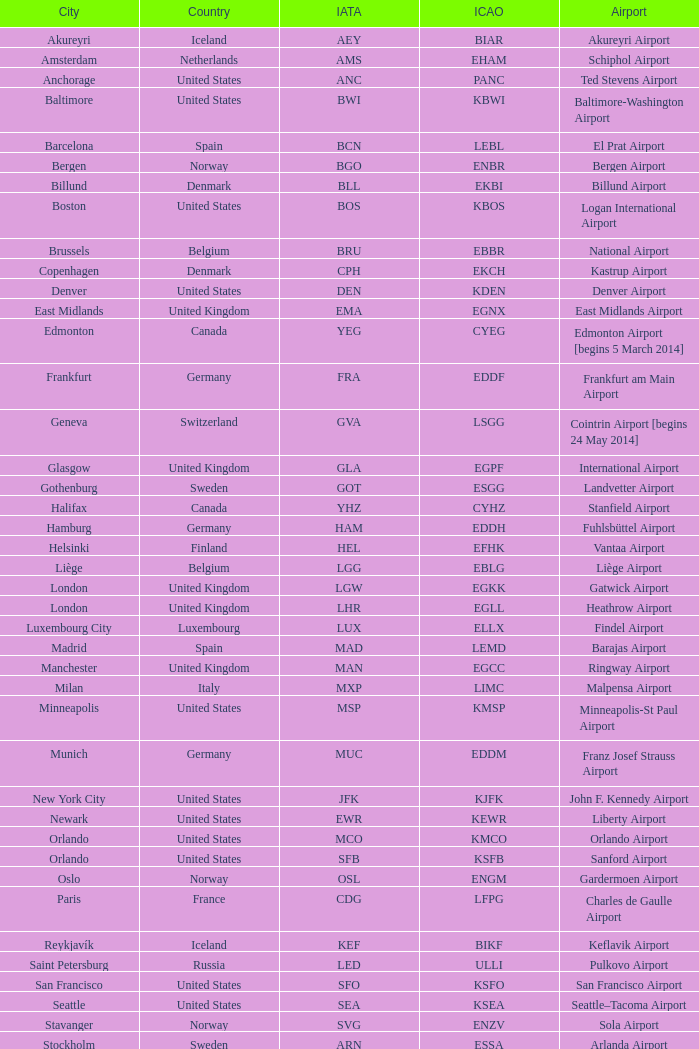What is the IATA OF Akureyri? AEY. 